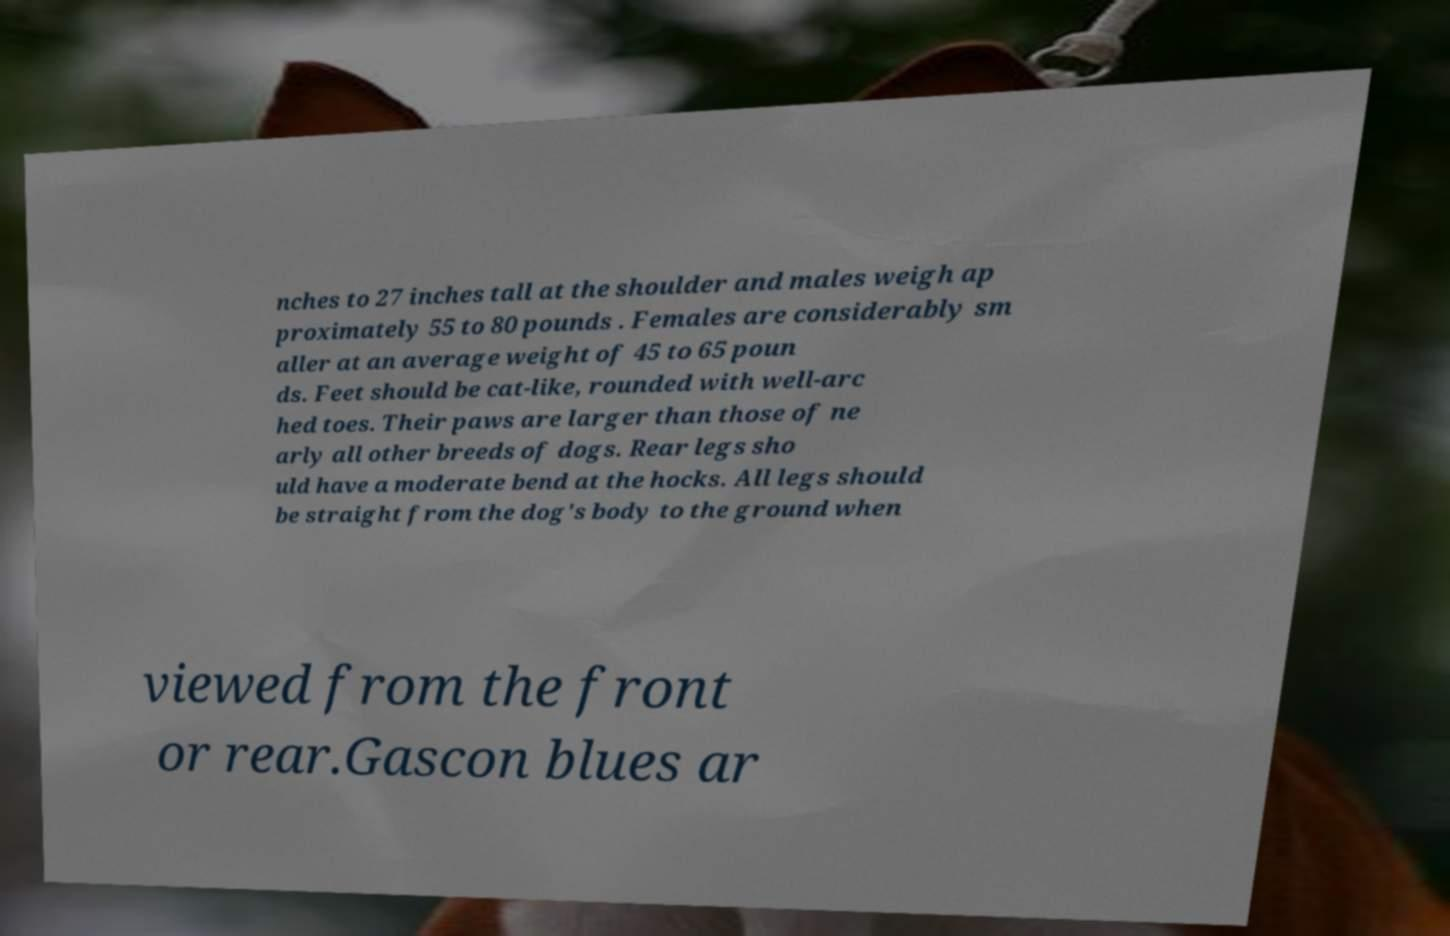Can you accurately transcribe the text from the provided image for me? nches to 27 inches tall at the shoulder and males weigh ap proximately 55 to 80 pounds . Females are considerably sm aller at an average weight of 45 to 65 poun ds. Feet should be cat-like, rounded with well-arc hed toes. Their paws are larger than those of ne arly all other breeds of dogs. Rear legs sho uld have a moderate bend at the hocks. All legs should be straight from the dog's body to the ground when viewed from the front or rear.Gascon blues ar 